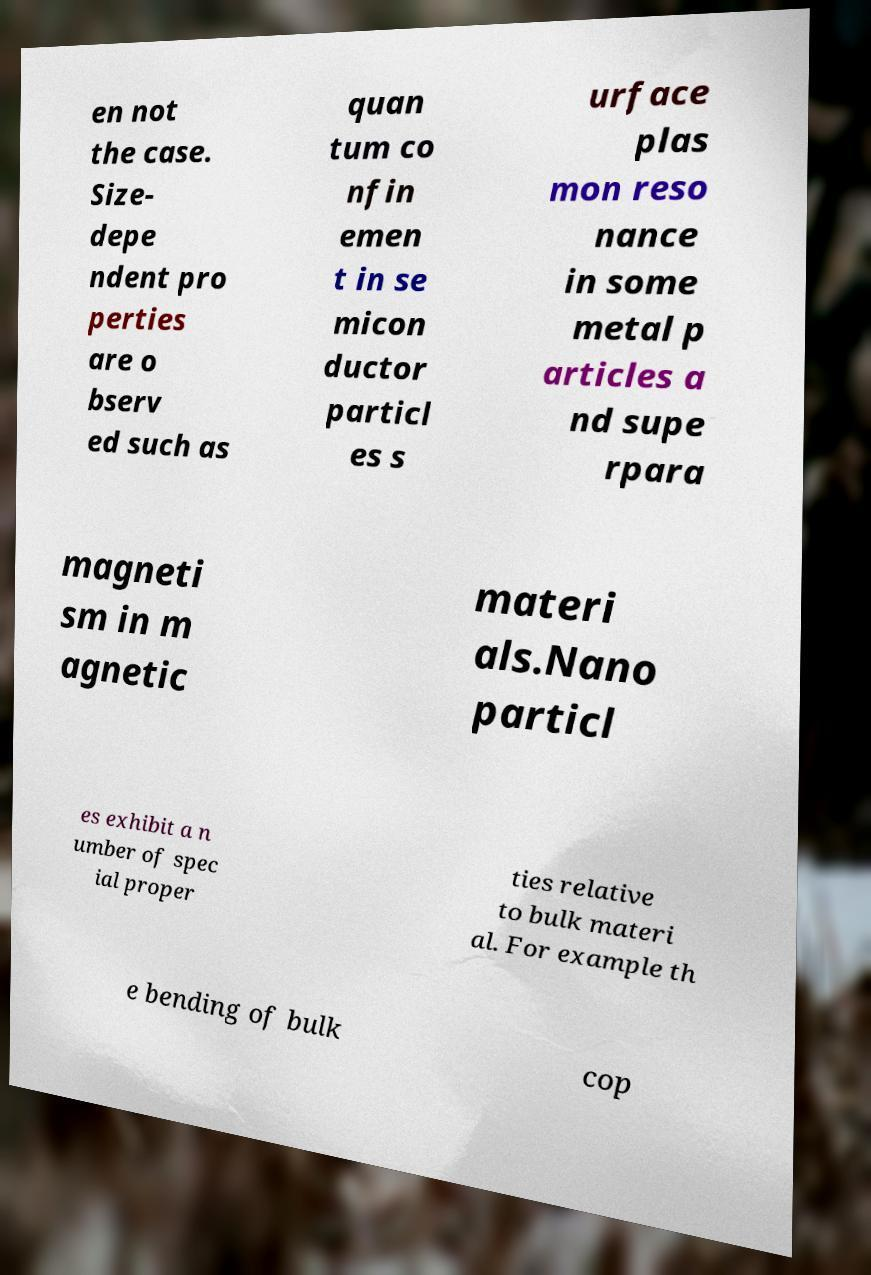Could you extract and type out the text from this image? en not the case. Size- depe ndent pro perties are o bserv ed such as quan tum co nfin emen t in se micon ductor particl es s urface plas mon reso nance in some metal p articles a nd supe rpara magneti sm in m agnetic materi als.Nano particl es exhibit a n umber of spec ial proper ties relative to bulk materi al. For example th e bending of bulk cop 